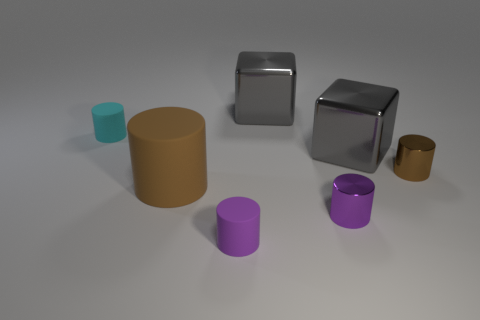What shape is the small object that is behind the block that is in front of the matte object that is behind the brown rubber thing?
Provide a succinct answer. Cylinder. What is the shape of the metallic object behind the small cyan matte cylinder?
Give a very brief answer. Cube. Is the material of the big cylinder the same as the gray block in front of the small cyan rubber cylinder?
Offer a very short reply. No. What number of other things are there of the same shape as the large matte thing?
Keep it short and to the point. 4. Is the color of the big cylinder the same as the cube in front of the cyan rubber cylinder?
Make the answer very short. No. Are there any other things that are made of the same material as the small cyan cylinder?
Offer a very short reply. Yes. The metal object that is behind the tiny rubber cylinder behind the small purple rubber object is what shape?
Ensure brevity in your answer.  Cube. There is a shiny thing that is the same color as the big matte cylinder; what size is it?
Keep it short and to the point. Small. There is a rubber thing to the right of the big cylinder; does it have the same shape as the cyan matte thing?
Provide a short and direct response. Yes. Is the number of tiny purple shiny cylinders that are on the left side of the small purple metal cylinder greater than the number of cyan cylinders behind the cyan object?
Your answer should be very brief. No. 